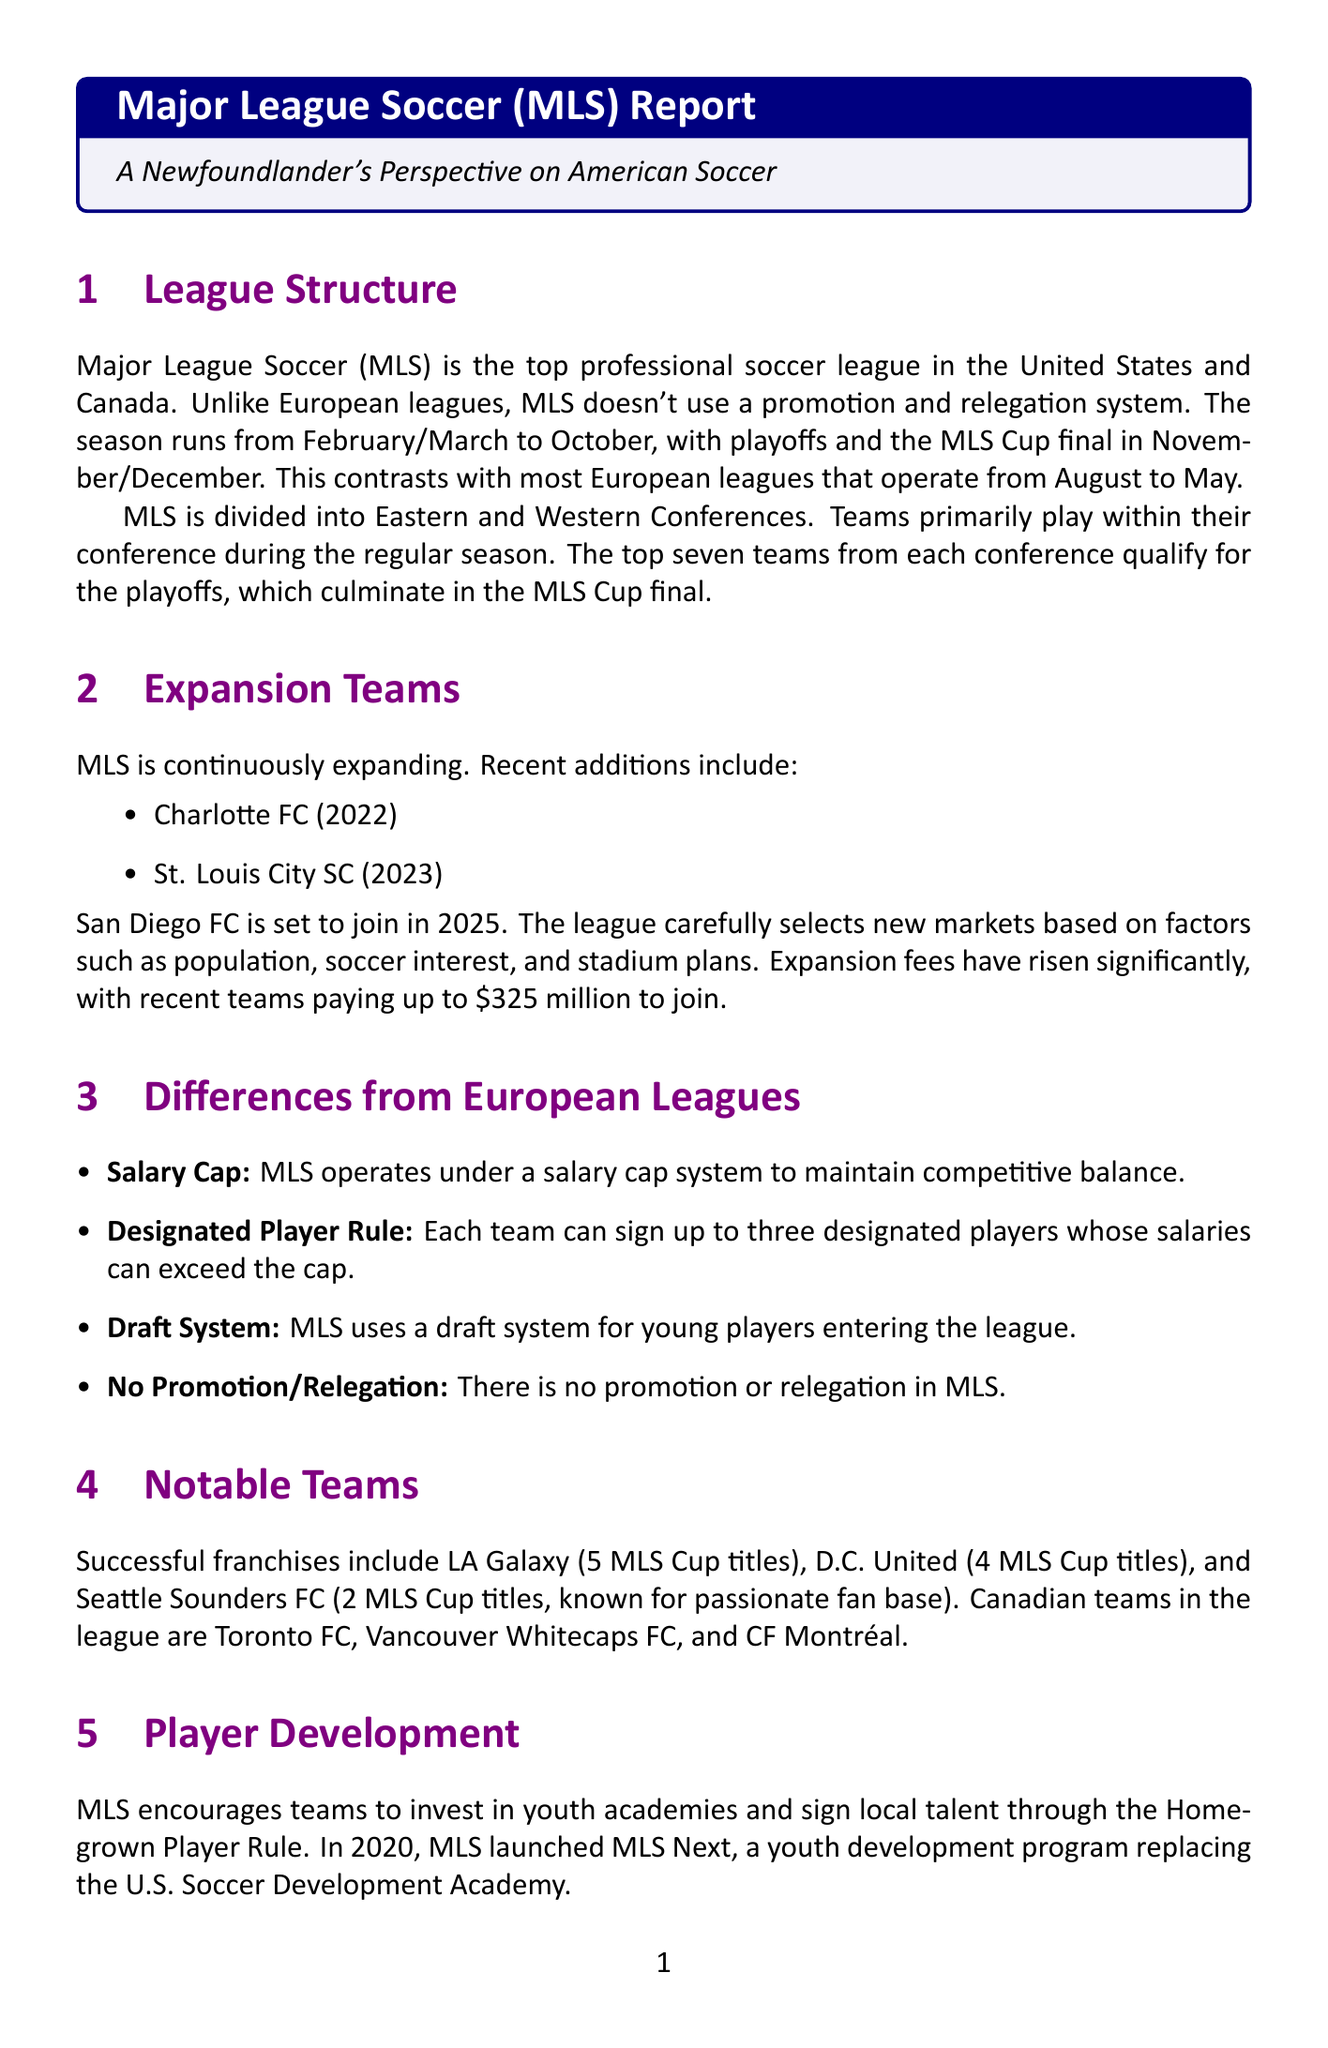What is the top professional soccer league in the U.S.? The document states that Major League Soccer (MLS) is the top professional soccer league in the United States and Canada.
Answer: Major League Soccer (MLS) When does the MLS season typically start? The season runs from February/March according to the league structure section.
Answer: February/March How many teams from each conference qualify for the MLS playoffs? According to the playoff system information, the top seven teams from each conference qualify for the playoffs.
Answer: Seven What is the expansion fee for recent MLS teams? The document mentions that recent teams have paid up to $325 million to join the league as part of the expansion process.
Answer: $325 million What unique rule does MLS use for high-profile signings? The designated player rule allows teams to sign players whose salaries can exceed the cap.
Answer: Designated player rule Which team has the most MLS Cup titles? The document states LA Galaxy has 5 MLS Cup titles, making it the team with the most titles in the league.
Answer: LA Galaxy What streaming service has a deal with MLS starting in 2023? The media coverage section indicates that MLS has a 10-year deal with Apple TV+.
Answer: Apple TV+ Which Canadian teams are mentioned in the document? The notable teams section lists Toronto FC, Vancouver Whitecaps FC, and CF Montréal as Canadian teams.
Answer: Toronto FC, Vancouver Whitecaps FC, CF Montréal 